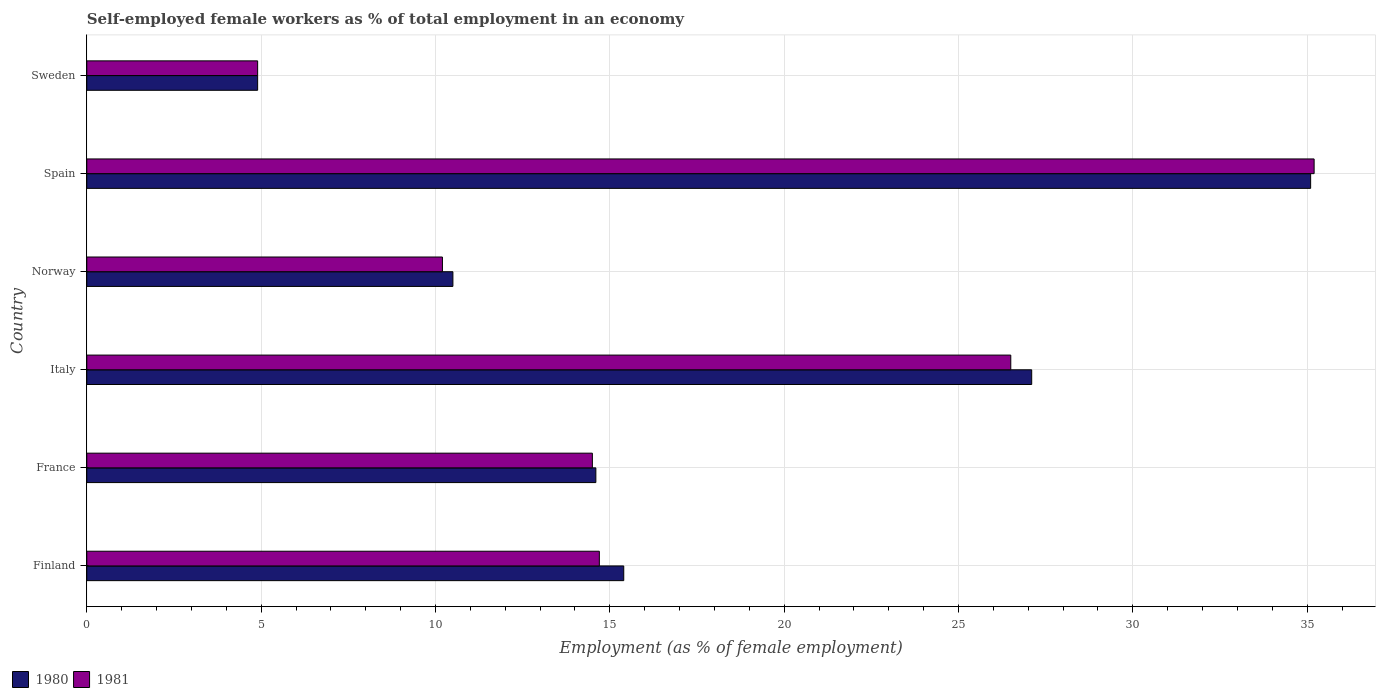In how many cases, is the number of bars for a given country not equal to the number of legend labels?
Give a very brief answer. 0. What is the percentage of self-employed female workers in 1981 in Sweden?
Your response must be concise. 4.9. Across all countries, what is the maximum percentage of self-employed female workers in 1981?
Your answer should be compact. 35.2. Across all countries, what is the minimum percentage of self-employed female workers in 1980?
Your answer should be very brief. 4.9. In which country was the percentage of self-employed female workers in 1980 maximum?
Give a very brief answer. Spain. In which country was the percentage of self-employed female workers in 1980 minimum?
Your response must be concise. Sweden. What is the total percentage of self-employed female workers in 1980 in the graph?
Your answer should be compact. 107.6. What is the difference between the percentage of self-employed female workers in 1981 in Italy and that in Norway?
Offer a very short reply. 16.3. What is the difference between the percentage of self-employed female workers in 1980 in Italy and the percentage of self-employed female workers in 1981 in Sweden?
Offer a very short reply. 22.2. What is the average percentage of self-employed female workers in 1980 per country?
Provide a succinct answer. 17.93. What is the difference between the percentage of self-employed female workers in 1980 and percentage of self-employed female workers in 1981 in France?
Keep it short and to the point. 0.1. In how many countries, is the percentage of self-employed female workers in 1981 greater than 30 %?
Offer a terse response. 1. What is the ratio of the percentage of self-employed female workers in 1980 in Norway to that in Sweden?
Make the answer very short. 2.14. Is the percentage of self-employed female workers in 1981 in Italy less than that in Norway?
Your answer should be compact. No. Is the difference between the percentage of self-employed female workers in 1980 in Italy and Norway greater than the difference between the percentage of self-employed female workers in 1981 in Italy and Norway?
Offer a terse response. Yes. What is the difference between the highest and the second highest percentage of self-employed female workers in 1981?
Ensure brevity in your answer.  8.7. What is the difference between the highest and the lowest percentage of self-employed female workers in 1981?
Offer a very short reply. 30.3. In how many countries, is the percentage of self-employed female workers in 1981 greater than the average percentage of self-employed female workers in 1981 taken over all countries?
Offer a terse response. 2. What does the 1st bar from the top in Finland represents?
Provide a succinct answer. 1981. What does the 2nd bar from the bottom in Sweden represents?
Keep it short and to the point. 1981. How many bars are there?
Offer a very short reply. 12. What is the difference between two consecutive major ticks on the X-axis?
Your answer should be very brief. 5. Does the graph contain any zero values?
Make the answer very short. No. What is the title of the graph?
Provide a succinct answer. Self-employed female workers as % of total employment in an economy. Does "1987" appear as one of the legend labels in the graph?
Give a very brief answer. No. What is the label or title of the X-axis?
Offer a very short reply. Employment (as % of female employment). What is the label or title of the Y-axis?
Provide a succinct answer. Country. What is the Employment (as % of female employment) of 1980 in Finland?
Offer a terse response. 15.4. What is the Employment (as % of female employment) in 1981 in Finland?
Offer a very short reply. 14.7. What is the Employment (as % of female employment) of 1980 in France?
Provide a succinct answer. 14.6. What is the Employment (as % of female employment) in 1981 in France?
Make the answer very short. 14.5. What is the Employment (as % of female employment) in 1980 in Italy?
Give a very brief answer. 27.1. What is the Employment (as % of female employment) in 1980 in Norway?
Make the answer very short. 10.5. What is the Employment (as % of female employment) of 1981 in Norway?
Your answer should be compact. 10.2. What is the Employment (as % of female employment) of 1980 in Spain?
Your answer should be compact. 35.1. What is the Employment (as % of female employment) in 1981 in Spain?
Your answer should be very brief. 35.2. What is the Employment (as % of female employment) in 1980 in Sweden?
Your answer should be very brief. 4.9. What is the Employment (as % of female employment) in 1981 in Sweden?
Offer a very short reply. 4.9. Across all countries, what is the maximum Employment (as % of female employment) of 1980?
Give a very brief answer. 35.1. Across all countries, what is the maximum Employment (as % of female employment) in 1981?
Keep it short and to the point. 35.2. Across all countries, what is the minimum Employment (as % of female employment) in 1980?
Keep it short and to the point. 4.9. Across all countries, what is the minimum Employment (as % of female employment) in 1981?
Offer a very short reply. 4.9. What is the total Employment (as % of female employment) in 1980 in the graph?
Give a very brief answer. 107.6. What is the total Employment (as % of female employment) of 1981 in the graph?
Provide a succinct answer. 106. What is the difference between the Employment (as % of female employment) of 1981 in Finland and that in France?
Your response must be concise. 0.2. What is the difference between the Employment (as % of female employment) of 1980 in Finland and that in Italy?
Offer a terse response. -11.7. What is the difference between the Employment (as % of female employment) of 1981 in Finland and that in Italy?
Make the answer very short. -11.8. What is the difference between the Employment (as % of female employment) of 1980 in Finland and that in Spain?
Give a very brief answer. -19.7. What is the difference between the Employment (as % of female employment) of 1981 in Finland and that in Spain?
Your response must be concise. -20.5. What is the difference between the Employment (as % of female employment) in 1981 in Finland and that in Sweden?
Your answer should be very brief. 9.8. What is the difference between the Employment (as % of female employment) of 1980 in France and that in Norway?
Offer a terse response. 4.1. What is the difference between the Employment (as % of female employment) of 1981 in France and that in Norway?
Offer a very short reply. 4.3. What is the difference between the Employment (as % of female employment) in 1980 in France and that in Spain?
Give a very brief answer. -20.5. What is the difference between the Employment (as % of female employment) of 1981 in France and that in Spain?
Give a very brief answer. -20.7. What is the difference between the Employment (as % of female employment) in 1980 in France and that in Sweden?
Provide a short and direct response. 9.7. What is the difference between the Employment (as % of female employment) in 1981 in Italy and that in Norway?
Provide a succinct answer. 16.3. What is the difference between the Employment (as % of female employment) of 1980 in Italy and that in Spain?
Ensure brevity in your answer.  -8. What is the difference between the Employment (as % of female employment) of 1981 in Italy and that in Spain?
Your answer should be very brief. -8.7. What is the difference between the Employment (as % of female employment) of 1980 in Italy and that in Sweden?
Offer a terse response. 22.2. What is the difference between the Employment (as % of female employment) in 1981 in Italy and that in Sweden?
Your answer should be compact. 21.6. What is the difference between the Employment (as % of female employment) in 1980 in Norway and that in Spain?
Provide a short and direct response. -24.6. What is the difference between the Employment (as % of female employment) of 1980 in Norway and that in Sweden?
Keep it short and to the point. 5.6. What is the difference between the Employment (as % of female employment) in 1981 in Norway and that in Sweden?
Make the answer very short. 5.3. What is the difference between the Employment (as % of female employment) in 1980 in Spain and that in Sweden?
Keep it short and to the point. 30.2. What is the difference between the Employment (as % of female employment) in 1981 in Spain and that in Sweden?
Provide a succinct answer. 30.3. What is the difference between the Employment (as % of female employment) of 1980 in Finland and the Employment (as % of female employment) of 1981 in France?
Offer a terse response. 0.9. What is the difference between the Employment (as % of female employment) in 1980 in Finland and the Employment (as % of female employment) in 1981 in Norway?
Your answer should be compact. 5.2. What is the difference between the Employment (as % of female employment) of 1980 in Finland and the Employment (as % of female employment) of 1981 in Spain?
Provide a succinct answer. -19.8. What is the difference between the Employment (as % of female employment) in 1980 in Finland and the Employment (as % of female employment) in 1981 in Sweden?
Keep it short and to the point. 10.5. What is the difference between the Employment (as % of female employment) in 1980 in France and the Employment (as % of female employment) in 1981 in Spain?
Offer a terse response. -20.6. What is the difference between the Employment (as % of female employment) of 1980 in France and the Employment (as % of female employment) of 1981 in Sweden?
Provide a succinct answer. 9.7. What is the difference between the Employment (as % of female employment) in 1980 in Italy and the Employment (as % of female employment) in 1981 in Spain?
Give a very brief answer. -8.1. What is the difference between the Employment (as % of female employment) in 1980 in Norway and the Employment (as % of female employment) in 1981 in Spain?
Your response must be concise. -24.7. What is the difference between the Employment (as % of female employment) in 1980 in Norway and the Employment (as % of female employment) in 1981 in Sweden?
Offer a terse response. 5.6. What is the difference between the Employment (as % of female employment) of 1980 in Spain and the Employment (as % of female employment) of 1981 in Sweden?
Provide a short and direct response. 30.2. What is the average Employment (as % of female employment) in 1980 per country?
Provide a short and direct response. 17.93. What is the average Employment (as % of female employment) in 1981 per country?
Your answer should be very brief. 17.67. What is the difference between the Employment (as % of female employment) in 1980 and Employment (as % of female employment) in 1981 in Italy?
Offer a very short reply. 0.6. What is the difference between the Employment (as % of female employment) of 1980 and Employment (as % of female employment) of 1981 in Norway?
Your answer should be very brief. 0.3. What is the difference between the Employment (as % of female employment) of 1980 and Employment (as % of female employment) of 1981 in Sweden?
Provide a short and direct response. 0. What is the ratio of the Employment (as % of female employment) of 1980 in Finland to that in France?
Give a very brief answer. 1.05. What is the ratio of the Employment (as % of female employment) in 1981 in Finland to that in France?
Give a very brief answer. 1.01. What is the ratio of the Employment (as % of female employment) of 1980 in Finland to that in Italy?
Offer a very short reply. 0.57. What is the ratio of the Employment (as % of female employment) in 1981 in Finland to that in Italy?
Offer a terse response. 0.55. What is the ratio of the Employment (as % of female employment) of 1980 in Finland to that in Norway?
Keep it short and to the point. 1.47. What is the ratio of the Employment (as % of female employment) in 1981 in Finland to that in Norway?
Offer a terse response. 1.44. What is the ratio of the Employment (as % of female employment) in 1980 in Finland to that in Spain?
Provide a short and direct response. 0.44. What is the ratio of the Employment (as % of female employment) in 1981 in Finland to that in Spain?
Keep it short and to the point. 0.42. What is the ratio of the Employment (as % of female employment) of 1980 in Finland to that in Sweden?
Keep it short and to the point. 3.14. What is the ratio of the Employment (as % of female employment) of 1980 in France to that in Italy?
Your answer should be very brief. 0.54. What is the ratio of the Employment (as % of female employment) of 1981 in France to that in Italy?
Provide a succinct answer. 0.55. What is the ratio of the Employment (as % of female employment) in 1980 in France to that in Norway?
Make the answer very short. 1.39. What is the ratio of the Employment (as % of female employment) of 1981 in France to that in Norway?
Offer a very short reply. 1.42. What is the ratio of the Employment (as % of female employment) in 1980 in France to that in Spain?
Your answer should be compact. 0.42. What is the ratio of the Employment (as % of female employment) of 1981 in France to that in Spain?
Ensure brevity in your answer.  0.41. What is the ratio of the Employment (as % of female employment) in 1980 in France to that in Sweden?
Your response must be concise. 2.98. What is the ratio of the Employment (as % of female employment) in 1981 in France to that in Sweden?
Offer a very short reply. 2.96. What is the ratio of the Employment (as % of female employment) of 1980 in Italy to that in Norway?
Give a very brief answer. 2.58. What is the ratio of the Employment (as % of female employment) of 1981 in Italy to that in Norway?
Ensure brevity in your answer.  2.6. What is the ratio of the Employment (as % of female employment) in 1980 in Italy to that in Spain?
Provide a succinct answer. 0.77. What is the ratio of the Employment (as % of female employment) in 1981 in Italy to that in Spain?
Your response must be concise. 0.75. What is the ratio of the Employment (as % of female employment) in 1980 in Italy to that in Sweden?
Keep it short and to the point. 5.53. What is the ratio of the Employment (as % of female employment) of 1981 in Italy to that in Sweden?
Offer a very short reply. 5.41. What is the ratio of the Employment (as % of female employment) in 1980 in Norway to that in Spain?
Make the answer very short. 0.3. What is the ratio of the Employment (as % of female employment) of 1981 in Norway to that in Spain?
Your answer should be compact. 0.29. What is the ratio of the Employment (as % of female employment) in 1980 in Norway to that in Sweden?
Offer a very short reply. 2.14. What is the ratio of the Employment (as % of female employment) in 1981 in Norway to that in Sweden?
Offer a very short reply. 2.08. What is the ratio of the Employment (as % of female employment) of 1980 in Spain to that in Sweden?
Your answer should be very brief. 7.16. What is the ratio of the Employment (as % of female employment) in 1981 in Spain to that in Sweden?
Your response must be concise. 7.18. What is the difference between the highest and the second highest Employment (as % of female employment) of 1980?
Make the answer very short. 8. What is the difference between the highest and the second highest Employment (as % of female employment) of 1981?
Offer a very short reply. 8.7. What is the difference between the highest and the lowest Employment (as % of female employment) in 1980?
Ensure brevity in your answer.  30.2. What is the difference between the highest and the lowest Employment (as % of female employment) of 1981?
Your response must be concise. 30.3. 